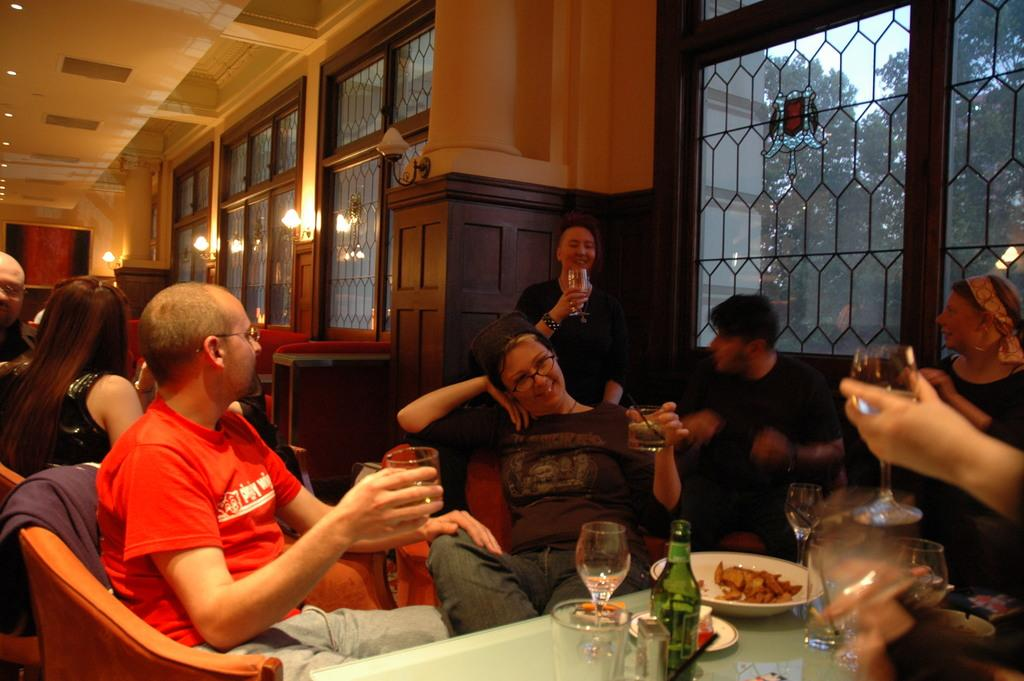How are the people in the image arranged? There are many people sitting on chairs in the image. What is in front of the chairs? The chairs are in front of a table. What can be seen on the table? There are many items present on the table. What is visible through the window in the room? Trees and the clear sky are visible through the window. What type of bell can be heard ringing in the image? There is no bell present or ringing in the image. What topic are the people discussing in the image? The image does not provide any information about a discussion or the topic being discussed. 